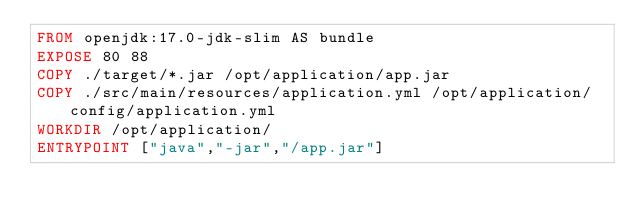Convert code to text. <code><loc_0><loc_0><loc_500><loc_500><_Dockerfile_>FROM openjdk:17.0-jdk-slim AS bundle
EXPOSE 80 88
COPY ./target/*.jar /opt/application/app.jar
COPY ./src/main/resources/application.yml /opt/application/config/application.yml
WORKDIR /opt/application/
ENTRYPOINT ["java","-jar","/app.jar"]</code> 